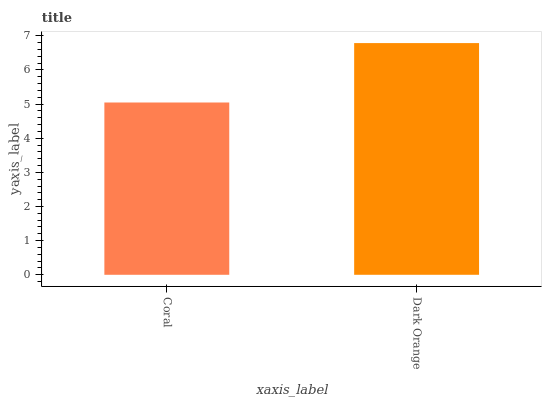Is Dark Orange the minimum?
Answer yes or no. No. Is Dark Orange greater than Coral?
Answer yes or no. Yes. Is Coral less than Dark Orange?
Answer yes or no. Yes. Is Coral greater than Dark Orange?
Answer yes or no. No. Is Dark Orange less than Coral?
Answer yes or no. No. Is Dark Orange the high median?
Answer yes or no. Yes. Is Coral the low median?
Answer yes or no. Yes. Is Coral the high median?
Answer yes or no. No. Is Dark Orange the low median?
Answer yes or no. No. 